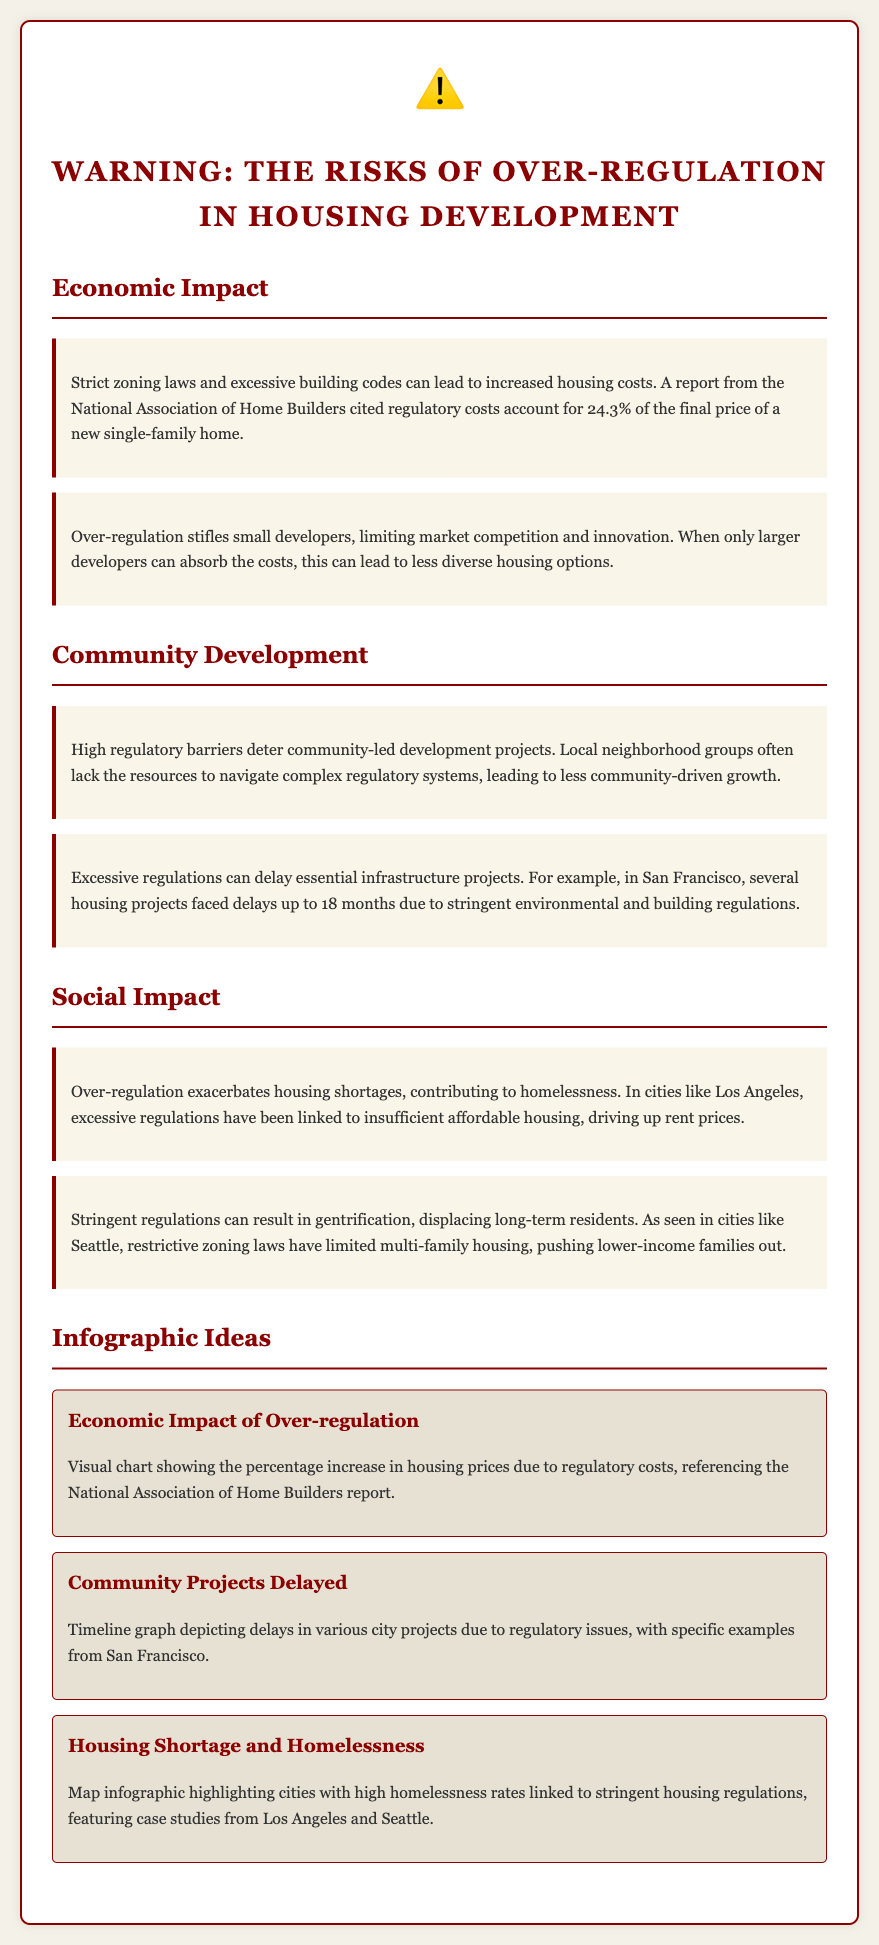what percentage of the final price of a new single-family home is attributed to regulatory costs? The document states that regulatory costs account for 24.3% of the final price of a new single-family home.
Answer: 24.3% what is one effect of over-regulation on small developers? The document mentions that over-regulation stifles small developers, limiting market competition and innovation.
Answer: Stifles competition which city faced delays of up to 18 months for housing projects due to regulations? The document provides San Francisco as an example where housing projects faced delays up to 18 months.
Answer: San Francisco how do excessive regulations contribute to homelessness? The document states that over-regulation exacerbates housing shortages, which is linked to homelessness.
Answer: Housing shortages what is one consequence of stringent regulations mentioned in relation to long-term residents? The document states that stringent regulations can result in gentrification, displacing long-term residents.
Answer: Gentrification what infographic idea highlights the economic impact of over-regulation? The document includes an infographic titled "Economic Impact of Over-regulation" that shows the percentage increase in housing prices due to regulatory costs.
Answer: Economic Impact of Over-regulation which two cities are mentioned as having high rates of homelessness linked to strict housing regulations? Los Angeles and Seattle are cited in the document regarding high homelessness rates due to stringent housing regulations.
Answer: Los Angeles and Seattle 